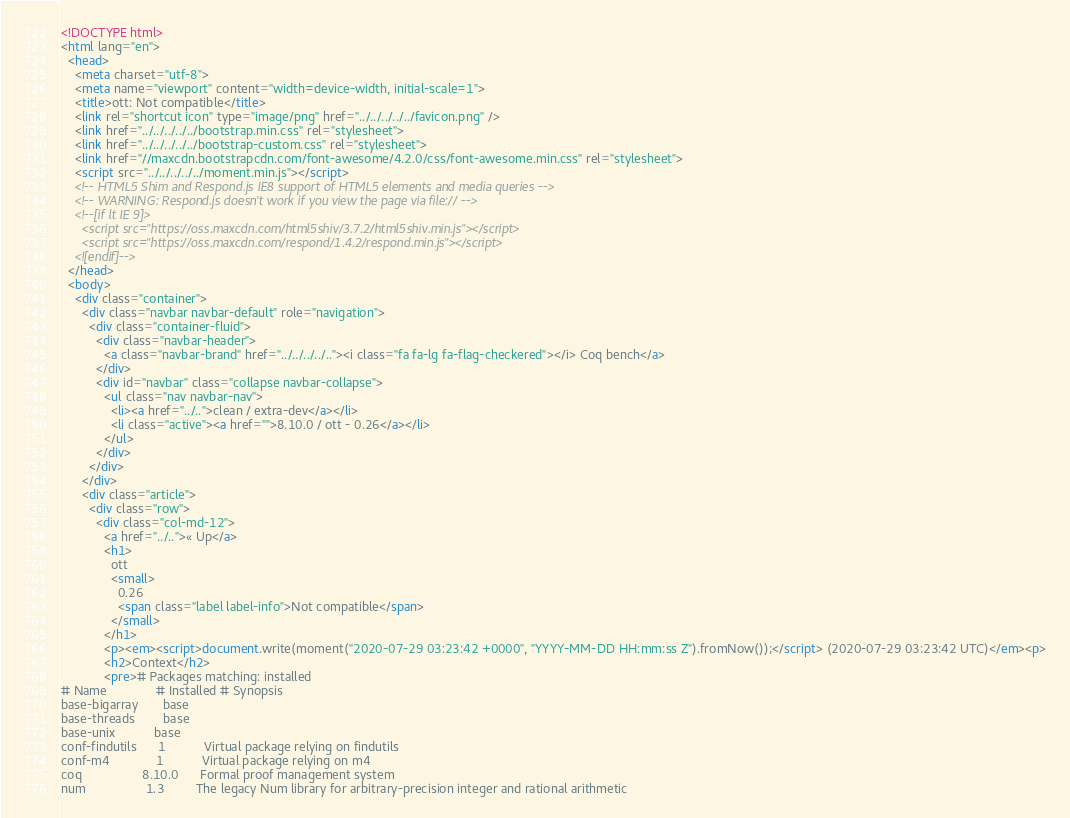<code> <loc_0><loc_0><loc_500><loc_500><_HTML_><!DOCTYPE html>
<html lang="en">
  <head>
    <meta charset="utf-8">
    <meta name="viewport" content="width=device-width, initial-scale=1">
    <title>ott: Not compatible</title>
    <link rel="shortcut icon" type="image/png" href="../../../../../favicon.png" />
    <link href="../../../../../bootstrap.min.css" rel="stylesheet">
    <link href="../../../../../bootstrap-custom.css" rel="stylesheet">
    <link href="//maxcdn.bootstrapcdn.com/font-awesome/4.2.0/css/font-awesome.min.css" rel="stylesheet">
    <script src="../../../../../moment.min.js"></script>
    <!-- HTML5 Shim and Respond.js IE8 support of HTML5 elements and media queries -->
    <!-- WARNING: Respond.js doesn't work if you view the page via file:// -->
    <!--[if lt IE 9]>
      <script src="https://oss.maxcdn.com/html5shiv/3.7.2/html5shiv.min.js"></script>
      <script src="https://oss.maxcdn.com/respond/1.4.2/respond.min.js"></script>
    <![endif]-->
  </head>
  <body>
    <div class="container">
      <div class="navbar navbar-default" role="navigation">
        <div class="container-fluid">
          <div class="navbar-header">
            <a class="navbar-brand" href="../../../../.."><i class="fa fa-lg fa-flag-checkered"></i> Coq bench</a>
          </div>
          <div id="navbar" class="collapse navbar-collapse">
            <ul class="nav navbar-nav">
              <li><a href="../..">clean / extra-dev</a></li>
              <li class="active"><a href="">8.10.0 / ott - 0.26</a></li>
            </ul>
          </div>
        </div>
      </div>
      <div class="article">
        <div class="row">
          <div class="col-md-12">
            <a href="../..">« Up</a>
            <h1>
              ott
              <small>
                0.26
                <span class="label label-info">Not compatible</span>
              </small>
            </h1>
            <p><em><script>document.write(moment("2020-07-29 03:23:42 +0000", "YYYY-MM-DD HH:mm:ss Z").fromNow());</script> (2020-07-29 03:23:42 UTC)</em><p>
            <h2>Context</h2>
            <pre># Packages matching: installed
# Name              # Installed # Synopsis
base-bigarray       base
base-threads        base
base-unix           base
conf-findutils      1           Virtual package relying on findutils
conf-m4             1           Virtual package relying on m4
coq                 8.10.0      Formal proof management system
num                 1.3         The legacy Num library for arbitrary-precision integer and rational arithmetic</code> 